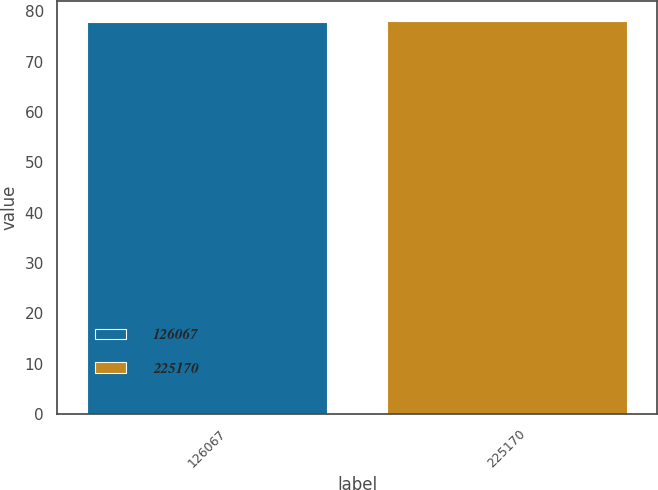<chart> <loc_0><loc_0><loc_500><loc_500><bar_chart><fcel>126067<fcel>225170<nl><fcel>78<fcel>78.1<nl></chart> 